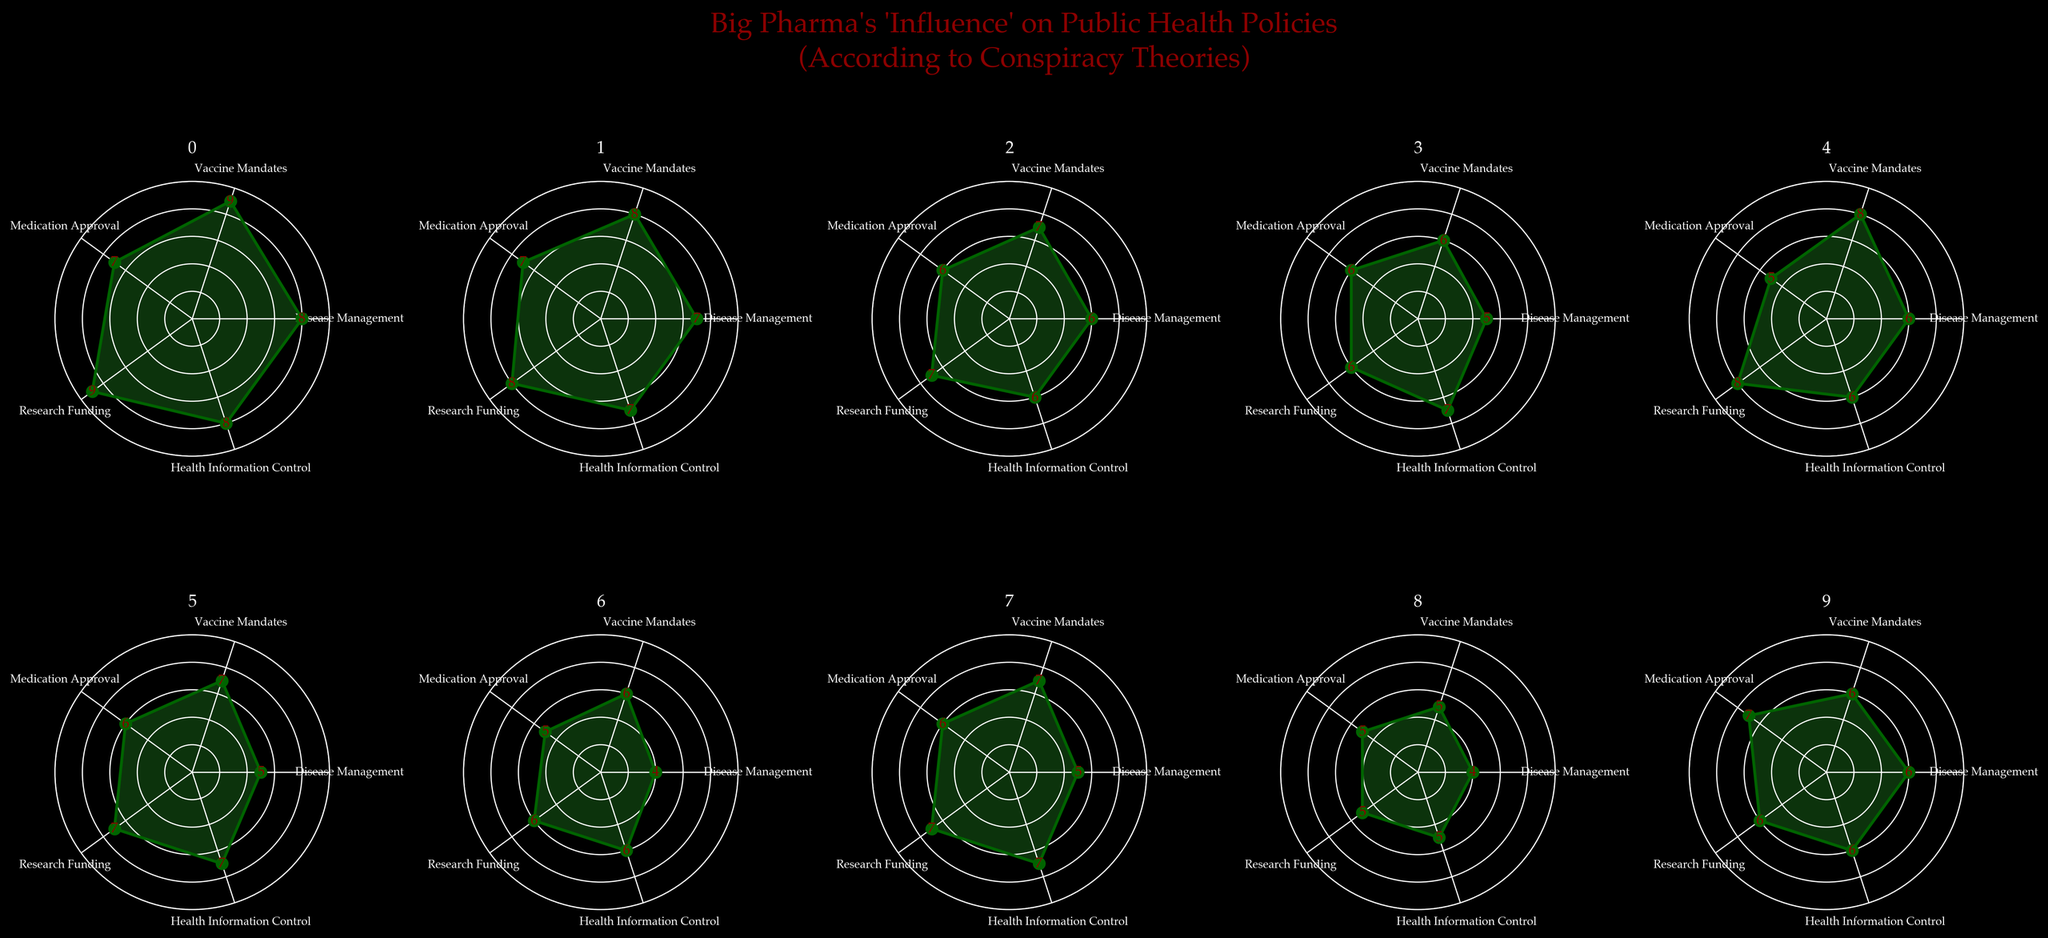What is the title of the figure? The title is usually above the plots, in a larger and bolder font than other text. In this figure, the title can be found at the top center above all the subplots. It reads: "Big Pharma's 'Influence' on Public Health Policies (According to Conspiracy Theories)"
Answer: Big Pharma's 'Influence' on Public Health Policies (According to Conspiracy Theories) How many pharmaceutical companies are compared in the figure? Each subplot represents one pharmaceutical company. Since the figure consists of 2 rows and 5 columns of subplots, it means there are 10 pharmaceutical companies displayed.
Answer: 10 Which category shows the highest influence for Pfizer? In Pfizer's subplot, the value is the highest in the "Vaccine Mandates" category (value = 9). This can be seen as the furthest point from the center in the radar chart and the highest marked value.
Answer: Vaccine Mandates Which categories have equal influence for Moderna? For Moderna, the influence values for "Vaccine Mandates" (8) and "Research Funding" (8) are the same, as indicated by identical distances from the center and identical numbers.
Answer: Vaccine Mandates and Research Funding Compare the "Medication Approval" influence between Johnson & Johnson and Merck. Which company has a higher value? Johnson & Johnson has an influence value of 6 in "Medication Approval," whereas Merck has an influence value of 6 as well. Since both values are equal, neither company has a higher value in this category.
Answer: Equal Which company has the least influence in "Health Information Control"? In the "Health Information Control" category, Bayer has the lowest influence value at 5, as indicated by the closest point to the center and the lowest number in this category.
Answer: Bayer What is the average "Research Funding" influence across all companies? To find the average "Research Funding" influence: Summing the values (9 + 8 + 7 + 6 + 8 + 7 + 6 + 7 + 5 + 6 = 69) and dividing by the number of companies (10). The average is 69 / 10 = 6.9
Answer: 6.9 Which company has the highest influence in "Disease Management"? Pfizer has the highest influence value of 8 in "Disease Management," as shown by the furthest point from the center in this category compared to other companies.
Answer: Pfizer Identify the company with the most balanced influence across all categories. Sanofi's radar chart has relatively similar values in all categories (4, 6, 5, 6, 6), indicating a balanced influence across all categories compared to other companies with more variance in their values.
Answer: Sanofi 